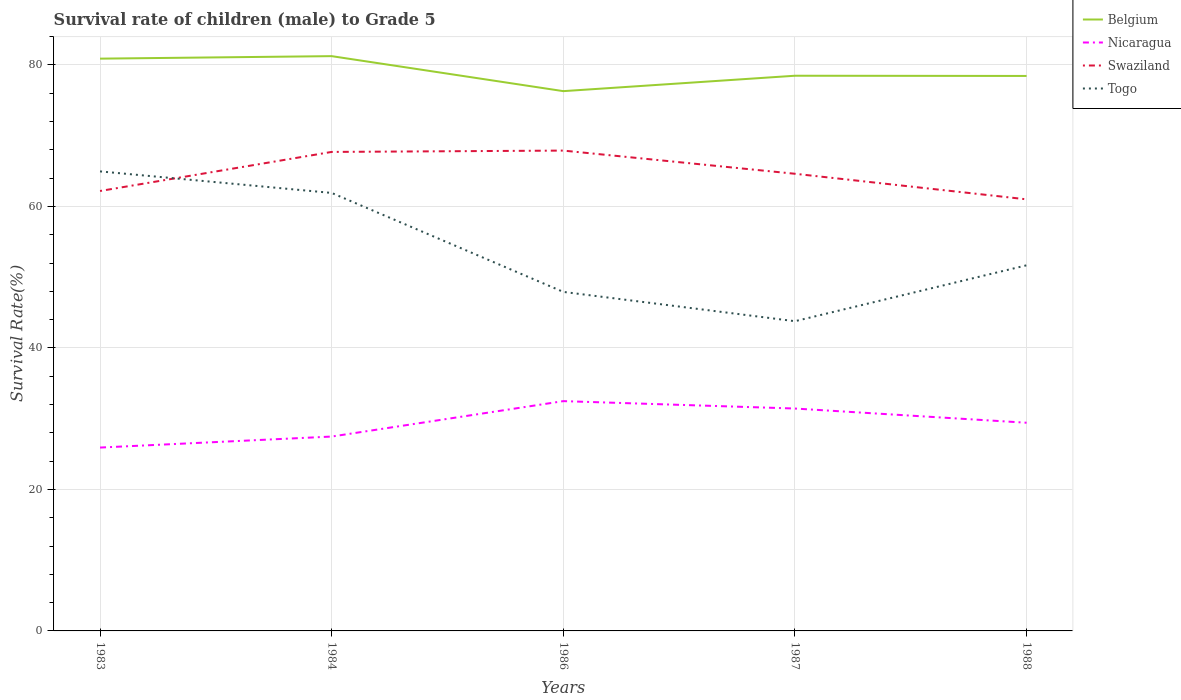How many different coloured lines are there?
Offer a very short reply. 4. Across all years, what is the maximum survival rate of male children to grade 5 in Swaziland?
Provide a succinct answer. 61.01. What is the total survival rate of male children to grade 5 in Belgium in the graph?
Ensure brevity in your answer.  2.8. What is the difference between the highest and the second highest survival rate of male children to grade 5 in Belgium?
Make the answer very short. 4.95. What is the difference between the highest and the lowest survival rate of male children to grade 5 in Swaziland?
Provide a succinct answer. 2. Is the survival rate of male children to grade 5 in Togo strictly greater than the survival rate of male children to grade 5 in Nicaragua over the years?
Your answer should be compact. No. How many lines are there?
Your answer should be very brief. 4. What is the difference between two consecutive major ticks on the Y-axis?
Offer a very short reply. 20. Does the graph contain any zero values?
Your answer should be very brief. No. Does the graph contain grids?
Keep it short and to the point. Yes. How many legend labels are there?
Give a very brief answer. 4. What is the title of the graph?
Give a very brief answer. Survival rate of children (male) to Grade 5. What is the label or title of the Y-axis?
Your answer should be very brief. Survival Rate(%). What is the Survival Rate(%) in Belgium in 1983?
Offer a terse response. 80.89. What is the Survival Rate(%) of Nicaragua in 1983?
Offer a terse response. 25.92. What is the Survival Rate(%) of Swaziland in 1983?
Give a very brief answer. 62.19. What is the Survival Rate(%) of Togo in 1983?
Provide a succinct answer. 64.96. What is the Survival Rate(%) in Belgium in 1984?
Your answer should be very brief. 81.25. What is the Survival Rate(%) of Nicaragua in 1984?
Your response must be concise. 27.47. What is the Survival Rate(%) of Swaziland in 1984?
Give a very brief answer. 67.71. What is the Survival Rate(%) in Togo in 1984?
Your response must be concise. 61.91. What is the Survival Rate(%) of Belgium in 1986?
Ensure brevity in your answer.  76.3. What is the Survival Rate(%) of Nicaragua in 1986?
Keep it short and to the point. 32.48. What is the Survival Rate(%) of Swaziland in 1986?
Provide a succinct answer. 67.9. What is the Survival Rate(%) of Togo in 1986?
Your answer should be very brief. 47.92. What is the Survival Rate(%) of Belgium in 1987?
Your answer should be compact. 78.48. What is the Survival Rate(%) of Nicaragua in 1987?
Make the answer very short. 31.44. What is the Survival Rate(%) in Swaziland in 1987?
Give a very brief answer. 64.62. What is the Survival Rate(%) of Togo in 1987?
Offer a terse response. 43.78. What is the Survival Rate(%) of Belgium in 1988?
Make the answer very short. 78.45. What is the Survival Rate(%) of Nicaragua in 1988?
Your response must be concise. 29.43. What is the Survival Rate(%) in Swaziland in 1988?
Offer a very short reply. 61.01. What is the Survival Rate(%) in Togo in 1988?
Ensure brevity in your answer.  51.68. Across all years, what is the maximum Survival Rate(%) of Belgium?
Offer a terse response. 81.25. Across all years, what is the maximum Survival Rate(%) of Nicaragua?
Offer a very short reply. 32.48. Across all years, what is the maximum Survival Rate(%) of Swaziland?
Offer a terse response. 67.9. Across all years, what is the maximum Survival Rate(%) in Togo?
Your answer should be very brief. 64.96. Across all years, what is the minimum Survival Rate(%) in Belgium?
Offer a terse response. 76.3. Across all years, what is the minimum Survival Rate(%) in Nicaragua?
Make the answer very short. 25.92. Across all years, what is the minimum Survival Rate(%) of Swaziland?
Offer a very short reply. 61.01. Across all years, what is the minimum Survival Rate(%) in Togo?
Give a very brief answer. 43.78. What is the total Survival Rate(%) of Belgium in the graph?
Your answer should be very brief. 395.36. What is the total Survival Rate(%) in Nicaragua in the graph?
Keep it short and to the point. 146.74. What is the total Survival Rate(%) of Swaziland in the graph?
Make the answer very short. 323.42. What is the total Survival Rate(%) in Togo in the graph?
Ensure brevity in your answer.  270.25. What is the difference between the Survival Rate(%) in Belgium in 1983 and that in 1984?
Keep it short and to the point. -0.35. What is the difference between the Survival Rate(%) of Nicaragua in 1983 and that in 1984?
Give a very brief answer. -1.56. What is the difference between the Survival Rate(%) in Swaziland in 1983 and that in 1984?
Your answer should be compact. -5.52. What is the difference between the Survival Rate(%) in Togo in 1983 and that in 1984?
Your answer should be very brief. 3.04. What is the difference between the Survival Rate(%) in Belgium in 1983 and that in 1986?
Offer a terse response. 4.59. What is the difference between the Survival Rate(%) in Nicaragua in 1983 and that in 1986?
Offer a terse response. -6.56. What is the difference between the Survival Rate(%) of Swaziland in 1983 and that in 1986?
Ensure brevity in your answer.  -5.71. What is the difference between the Survival Rate(%) of Togo in 1983 and that in 1986?
Your answer should be very brief. 17.03. What is the difference between the Survival Rate(%) in Belgium in 1983 and that in 1987?
Your answer should be compact. 2.41. What is the difference between the Survival Rate(%) of Nicaragua in 1983 and that in 1987?
Offer a very short reply. -5.52. What is the difference between the Survival Rate(%) of Swaziland in 1983 and that in 1987?
Offer a very short reply. -2.43. What is the difference between the Survival Rate(%) in Togo in 1983 and that in 1987?
Keep it short and to the point. 21.18. What is the difference between the Survival Rate(%) of Belgium in 1983 and that in 1988?
Provide a short and direct response. 2.45. What is the difference between the Survival Rate(%) in Nicaragua in 1983 and that in 1988?
Keep it short and to the point. -3.51. What is the difference between the Survival Rate(%) of Swaziland in 1983 and that in 1988?
Your answer should be compact. 1.18. What is the difference between the Survival Rate(%) in Togo in 1983 and that in 1988?
Offer a very short reply. 13.27. What is the difference between the Survival Rate(%) of Belgium in 1984 and that in 1986?
Provide a short and direct response. 4.95. What is the difference between the Survival Rate(%) in Nicaragua in 1984 and that in 1986?
Your response must be concise. -5.01. What is the difference between the Survival Rate(%) of Swaziland in 1984 and that in 1986?
Your response must be concise. -0.19. What is the difference between the Survival Rate(%) of Togo in 1984 and that in 1986?
Offer a terse response. 13.99. What is the difference between the Survival Rate(%) in Belgium in 1984 and that in 1987?
Provide a short and direct response. 2.77. What is the difference between the Survival Rate(%) in Nicaragua in 1984 and that in 1987?
Make the answer very short. -3.96. What is the difference between the Survival Rate(%) of Swaziland in 1984 and that in 1987?
Your answer should be very brief. 3.09. What is the difference between the Survival Rate(%) of Togo in 1984 and that in 1987?
Make the answer very short. 18.13. What is the difference between the Survival Rate(%) of Belgium in 1984 and that in 1988?
Provide a short and direct response. 2.8. What is the difference between the Survival Rate(%) in Nicaragua in 1984 and that in 1988?
Give a very brief answer. -1.95. What is the difference between the Survival Rate(%) of Swaziland in 1984 and that in 1988?
Offer a terse response. 6.7. What is the difference between the Survival Rate(%) in Togo in 1984 and that in 1988?
Your response must be concise. 10.23. What is the difference between the Survival Rate(%) in Belgium in 1986 and that in 1987?
Make the answer very short. -2.18. What is the difference between the Survival Rate(%) in Nicaragua in 1986 and that in 1987?
Keep it short and to the point. 1.05. What is the difference between the Survival Rate(%) of Swaziland in 1986 and that in 1987?
Give a very brief answer. 3.28. What is the difference between the Survival Rate(%) of Togo in 1986 and that in 1987?
Provide a short and direct response. 4.14. What is the difference between the Survival Rate(%) in Belgium in 1986 and that in 1988?
Your answer should be compact. -2.15. What is the difference between the Survival Rate(%) in Nicaragua in 1986 and that in 1988?
Ensure brevity in your answer.  3.05. What is the difference between the Survival Rate(%) in Swaziland in 1986 and that in 1988?
Offer a very short reply. 6.89. What is the difference between the Survival Rate(%) of Togo in 1986 and that in 1988?
Your answer should be compact. -3.76. What is the difference between the Survival Rate(%) in Belgium in 1987 and that in 1988?
Keep it short and to the point. 0.03. What is the difference between the Survival Rate(%) in Nicaragua in 1987 and that in 1988?
Keep it short and to the point. 2.01. What is the difference between the Survival Rate(%) in Swaziland in 1987 and that in 1988?
Your answer should be very brief. 3.61. What is the difference between the Survival Rate(%) in Togo in 1987 and that in 1988?
Your response must be concise. -7.9. What is the difference between the Survival Rate(%) in Belgium in 1983 and the Survival Rate(%) in Nicaragua in 1984?
Your answer should be compact. 53.42. What is the difference between the Survival Rate(%) of Belgium in 1983 and the Survival Rate(%) of Swaziland in 1984?
Your answer should be very brief. 13.18. What is the difference between the Survival Rate(%) of Belgium in 1983 and the Survival Rate(%) of Togo in 1984?
Give a very brief answer. 18.98. What is the difference between the Survival Rate(%) of Nicaragua in 1983 and the Survival Rate(%) of Swaziland in 1984?
Your answer should be very brief. -41.79. What is the difference between the Survival Rate(%) in Nicaragua in 1983 and the Survival Rate(%) in Togo in 1984?
Provide a short and direct response. -35.99. What is the difference between the Survival Rate(%) of Swaziland in 1983 and the Survival Rate(%) of Togo in 1984?
Your response must be concise. 0.27. What is the difference between the Survival Rate(%) of Belgium in 1983 and the Survival Rate(%) of Nicaragua in 1986?
Your answer should be compact. 48.41. What is the difference between the Survival Rate(%) of Belgium in 1983 and the Survival Rate(%) of Swaziland in 1986?
Your answer should be very brief. 13. What is the difference between the Survival Rate(%) of Belgium in 1983 and the Survival Rate(%) of Togo in 1986?
Provide a short and direct response. 32.97. What is the difference between the Survival Rate(%) of Nicaragua in 1983 and the Survival Rate(%) of Swaziland in 1986?
Make the answer very short. -41.98. What is the difference between the Survival Rate(%) of Nicaragua in 1983 and the Survival Rate(%) of Togo in 1986?
Ensure brevity in your answer.  -22. What is the difference between the Survival Rate(%) in Swaziland in 1983 and the Survival Rate(%) in Togo in 1986?
Your answer should be compact. 14.26. What is the difference between the Survival Rate(%) of Belgium in 1983 and the Survival Rate(%) of Nicaragua in 1987?
Your answer should be very brief. 49.46. What is the difference between the Survival Rate(%) of Belgium in 1983 and the Survival Rate(%) of Swaziland in 1987?
Your response must be concise. 16.27. What is the difference between the Survival Rate(%) in Belgium in 1983 and the Survival Rate(%) in Togo in 1987?
Your answer should be very brief. 37.11. What is the difference between the Survival Rate(%) in Nicaragua in 1983 and the Survival Rate(%) in Swaziland in 1987?
Offer a very short reply. -38.7. What is the difference between the Survival Rate(%) in Nicaragua in 1983 and the Survival Rate(%) in Togo in 1987?
Make the answer very short. -17.86. What is the difference between the Survival Rate(%) in Swaziland in 1983 and the Survival Rate(%) in Togo in 1987?
Your answer should be very brief. 18.41. What is the difference between the Survival Rate(%) in Belgium in 1983 and the Survival Rate(%) in Nicaragua in 1988?
Make the answer very short. 51.46. What is the difference between the Survival Rate(%) in Belgium in 1983 and the Survival Rate(%) in Swaziland in 1988?
Keep it short and to the point. 19.89. What is the difference between the Survival Rate(%) in Belgium in 1983 and the Survival Rate(%) in Togo in 1988?
Offer a very short reply. 29.21. What is the difference between the Survival Rate(%) in Nicaragua in 1983 and the Survival Rate(%) in Swaziland in 1988?
Offer a terse response. -35.09. What is the difference between the Survival Rate(%) in Nicaragua in 1983 and the Survival Rate(%) in Togo in 1988?
Offer a very short reply. -25.76. What is the difference between the Survival Rate(%) in Swaziland in 1983 and the Survival Rate(%) in Togo in 1988?
Give a very brief answer. 10.5. What is the difference between the Survival Rate(%) of Belgium in 1984 and the Survival Rate(%) of Nicaragua in 1986?
Offer a very short reply. 48.76. What is the difference between the Survival Rate(%) in Belgium in 1984 and the Survival Rate(%) in Swaziland in 1986?
Your answer should be compact. 13.35. What is the difference between the Survival Rate(%) in Belgium in 1984 and the Survival Rate(%) in Togo in 1986?
Your answer should be very brief. 33.32. What is the difference between the Survival Rate(%) of Nicaragua in 1984 and the Survival Rate(%) of Swaziland in 1986?
Offer a very short reply. -40.42. What is the difference between the Survival Rate(%) of Nicaragua in 1984 and the Survival Rate(%) of Togo in 1986?
Offer a terse response. -20.45. What is the difference between the Survival Rate(%) in Swaziland in 1984 and the Survival Rate(%) in Togo in 1986?
Ensure brevity in your answer.  19.79. What is the difference between the Survival Rate(%) of Belgium in 1984 and the Survival Rate(%) of Nicaragua in 1987?
Provide a short and direct response. 49.81. What is the difference between the Survival Rate(%) of Belgium in 1984 and the Survival Rate(%) of Swaziland in 1987?
Offer a terse response. 16.63. What is the difference between the Survival Rate(%) in Belgium in 1984 and the Survival Rate(%) in Togo in 1987?
Give a very brief answer. 37.47. What is the difference between the Survival Rate(%) in Nicaragua in 1984 and the Survival Rate(%) in Swaziland in 1987?
Make the answer very short. -37.15. What is the difference between the Survival Rate(%) of Nicaragua in 1984 and the Survival Rate(%) of Togo in 1987?
Your answer should be very brief. -16.31. What is the difference between the Survival Rate(%) of Swaziland in 1984 and the Survival Rate(%) of Togo in 1987?
Provide a short and direct response. 23.93. What is the difference between the Survival Rate(%) of Belgium in 1984 and the Survival Rate(%) of Nicaragua in 1988?
Ensure brevity in your answer.  51.82. What is the difference between the Survival Rate(%) in Belgium in 1984 and the Survival Rate(%) in Swaziland in 1988?
Provide a succinct answer. 20.24. What is the difference between the Survival Rate(%) of Belgium in 1984 and the Survival Rate(%) of Togo in 1988?
Provide a short and direct response. 29.56. What is the difference between the Survival Rate(%) in Nicaragua in 1984 and the Survival Rate(%) in Swaziland in 1988?
Your answer should be very brief. -33.53. What is the difference between the Survival Rate(%) of Nicaragua in 1984 and the Survival Rate(%) of Togo in 1988?
Ensure brevity in your answer.  -24.21. What is the difference between the Survival Rate(%) in Swaziland in 1984 and the Survival Rate(%) in Togo in 1988?
Ensure brevity in your answer.  16.03. What is the difference between the Survival Rate(%) in Belgium in 1986 and the Survival Rate(%) in Nicaragua in 1987?
Provide a succinct answer. 44.86. What is the difference between the Survival Rate(%) in Belgium in 1986 and the Survival Rate(%) in Swaziland in 1987?
Your answer should be very brief. 11.68. What is the difference between the Survival Rate(%) in Belgium in 1986 and the Survival Rate(%) in Togo in 1987?
Provide a short and direct response. 32.52. What is the difference between the Survival Rate(%) of Nicaragua in 1986 and the Survival Rate(%) of Swaziland in 1987?
Your response must be concise. -32.14. What is the difference between the Survival Rate(%) in Nicaragua in 1986 and the Survival Rate(%) in Togo in 1987?
Offer a terse response. -11.3. What is the difference between the Survival Rate(%) of Swaziland in 1986 and the Survival Rate(%) of Togo in 1987?
Provide a short and direct response. 24.12. What is the difference between the Survival Rate(%) of Belgium in 1986 and the Survival Rate(%) of Nicaragua in 1988?
Your answer should be compact. 46.87. What is the difference between the Survival Rate(%) of Belgium in 1986 and the Survival Rate(%) of Swaziland in 1988?
Your response must be concise. 15.29. What is the difference between the Survival Rate(%) of Belgium in 1986 and the Survival Rate(%) of Togo in 1988?
Offer a very short reply. 24.62. What is the difference between the Survival Rate(%) in Nicaragua in 1986 and the Survival Rate(%) in Swaziland in 1988?
Make the answer very short. -28.53. What is the difference between the Survival Rate(%) of Nicaragua in 1986 and the Survival Rate(%) of Togo in 1988?
Ensure brevity in your answer.  -19.2. What is the difference between the Survival Rate(%) of Swaziland in 1986 and the Survival Rate(%) of Togo in 1988?
Ensure brevity in your answer.  16.22. What is the difference between the Survival Rate(%) of Belgium in 1987 and the Survival Rate(%) of Nicaragua in 1988?
Your answer should be very brief. 49.05. What is the difference between the Survival Rate(%) of Belgium in 1987 and the Survival Rate(%) of Swaziland in 1988?
Give a very brief answer. 17.47. What is the difference between the Survival Rate(%) of Belgium in 1987 and the Survival Rate(%) of Togo in 1988?
Keep it short and to the point. 26.8. What is the difference between the Survival Rate(%) in Nicaragua in 1987 and the Survival Rate(%) in Swaziland in 1988?
Offer a terse response. -29.57. What is the difference between the Survival Rate(%) in Nicaragua in 1987 and the Survival Rate(%) in Togo in 1988?
Your answer should be compact. -20.25. What is the difference between the Survival Rate(%) in Swaziland in 1987 and the Survival Rate(%) in Togo in 1988?
Your answer should be compact. 12.94. What is the average Survival Rate(%) of Belgium per year?
Offer a terse response. 79.07. What is the average Survival Rate(%) in Nicaragua per year?
Make the answer very short. 29.35. What is the average Survival Rate(%) in Swaziland per year?
Your answer should be compact. 64.68. What is the average Survival Rate(%) of Togo per year?
Provide a short and direct response. 54.05. In the year 1983, what is the difference between the Survival Rate(%) in Belgium and Survival Rate(%) in Nicaragua?
Your answer should be compact. 54.97. In the year 1983, what is the difference between the Survival Rate(%) of Belgium and Survival Rate(%) of Swaziland?
Keep it short and to the point. 18.71. In the year 1983, what is the difference between the Survival Rate(%) in Belgium and Survival Rate(%) in Togo?
Ensure brevity in your answer.  15.94. In the year 1983, what is the difference between the Survival Rate(%) of Nicaragua and Survival Rate(%) of Swaziland?
Your answer should be very brief. -36.27. In the year 1983, what is the difference between the Survival Rate(%) of Nicaragua and Survival Rate(%) of Togo?
Offer a terse response. -39.04. In the year 1983, what is the difference between the Survival Rate(%) of Swaziland and Survival Rate(%) of Togo?
Ensure brevity in your answer.  -2.77. In the year 1984, what is the difference between the Survival Rate(%) in Belgium and Survival Rate(%) in Nicaragua?
Offer a terse response. 53.77. In the year 1984, what is the difference between the Survival Rate(%) in Belgium and Survival Rate(%) in Swaziland?
Offer a very short reply. 13.54. In the year 1984, what is the difference between the Survival Rate(%) in Belgium and Survival Rate(%) in Togo?
Make the answer very short. 19.33. In the year 1984, what is the difference between the Survival Rate(%) in Nicaragua and Survival Rate(%) in Swaziland?
Give a very brief answer. -40.23. In the year 1984, what is the difference between the Survival Rate(%) of Nicaragua and Survival Rate(%) of Togo?
Ensure brevity in your answer.  -34.44. In the year 1984, what is the difference between the Survival Rate(%) of Swaziland and Survival Rate(%) of Togo?
Offer a terse response. 5.8. In the year 1986, what is the difference between the Survival Rate(%) of Belgium and Survival Rate(%) of Nicaragua?
Offer a very short reply. 43.82. In the year 1986, what is the difference between the Survival Rate(%) in Belgium and Survival Rate(%) in Swaziland?
Provide a short and direct response. 8.4. In the year 1986, what is the difference between the Survival Rate(%) in Belgium and Survival Rate(%) in Togo?
Provide a succinct answer. 28.38. In the year 1986, what is the difference between the Survival Rate(%) in Nicaragua and Survival Rate(%) in Swaziland?
Your answer should be very brief. -35.42. In the year 1986, what is the difference between the Survival Rate(%) of Nicaragua and Survival Rate(%) of Togo?
Your answer should be compact. -15.44. In the year 1986, what is the difference between the Survival Rate(%) in Swaziland and Survival Rate(%) in Togo?
Keep it short and to the point. 19.98. In the year 1987, what is the difference between the Survival Rate(%) of Belgium and Survival Rate(%) of Nicaragua?
Ensure brevity in your answer.  47.04. In the year 1987, what is the difference between the Survival Rate(%) of Belgium and Survival Rate(%) of Swaziland?
Ensure brevity in your answer.  13.86. In the year 1987, what is the difference between the Survival Rate(%) of Belgium and Survival Rate(%) of Togo?
Your response must be concise. 34.7. In the year 1987, what is the difference between the Survival Rate(%) in Nicaragua and Survival Rate(%) in Swaziland?
Your response must be concise. -33.18. In the year 1987, what is the difference between the Survival Rate(%) in Nicaragua and Survival Rate(%) in Togo?
Keep it short and to the point. -12.34. In the year 1987, what is the difference between the Survival Rate(%) of Swaziland and Survival Rate(%) of Togo?
Provide a short and direct response. 20.84. In the year 1988, what is the difference between the Survival Rate(%) in Belgium and Survival Rate(%) in Nicaragua?
Make the answer very short. 49.02. In the year 1988, what is the difference between the Survival Rate(%) in Belgium and Survival Rate(%) in Swaziland?
Your answer should be very brief. 17.44. In the year 1988, what is the difference between the Survival Rate(%) of Belgium and Survival Rate(%) of Togo?
Keep it short and to the point. 26.77. In the year 1988, what is the difference between the Survival Rate(%) in Nicaragua and Survival Rate(%) in Swaziland?
Offer a terse response. -31.58. In the year 1988, what is the difference between the Survival Rate(%) of Nicaragua and Survival Rate(%) of Togo?
Make the answer very short. -22.25. In the year 1988, what is the difference between the Survival Rate(%) in Swaziland and Survival Rate(%) in Togo?
Provide a short and direct response. 9.33. What is the ratio of the Survival Rate(%) in Belgium in 1983 to that in 1984?
Keep it short and to the point. 1. What is the ratio of the Survival Rate(%) in Nicaragua in 1983 to that in 1984?
Keep it short and to the point. 0.94. What is the ratio of the Survival Rate(%) of Swaziland in 1983 to that in 1984?
Keep it short and to the point. 0.92. What is the ratio of the Survival Rate(%) of Togo in 1983 to that in 1984?
Make the answer very short. 1.05. What is the ratio of the Survival Rate(%) of Belgium in 1983 to that in 1986?
Make the answer very short. 1.06. What is the ratio of the Survival Rate(%) in Nicaragua in 1983 to that in 1986?
Your response must be concise. 0.8. What is the ratio of the Survival Rate(%) of Swaziland in 1983 to that in 1986?
Your response must be concise. 0.92. What is the ratio of the Survival Rate(%) in Togo in 1983 to that in 1986?
Keep it short and to the point. 1.36. What is the ratio of the Survival Rate(%) of Belgium in 1983 to that in 1987?
Your answer should be very brief. 1.03. What is the ratio of the Survival Rate(%) of Nicaragua in 1983 to that in 1987?
Ensure brevity in your answer.  0.82. What is the ratio of the Survival Rate(%) in Swaziland in 1983 to that in 1987?
Your answer should be compact. 0.96. What is the ratio of the Survival Rate(%) in Togo in 1983 to that in 1987?
Your answer should be very brief. 1.48. What is the ratio of the Survival Rate(%) in Belgium in 1983 to that in 1988?
Provide a succinct answer. 1.03. What is the ratio of the Survival Rate(%) in Nicaragua in 1983 to that in 1988?
Your response must be concise. 0.88. What is the ratio of the Survival Rate(%) in Swaziland in 1983 to that in 1988?
Keep it short and to the point. 1.02. What is the ratio of the Survival Rate(%) in Togo in 1983 to that in 1988?
Offer a terse response. 1.26. What is the ratio of the Survival Rate(%) in Belgium in 1984 to that in 1986?
Provide a succinct answer. 1.06. What is the ratio of the Survival Rate(%) of Nicaragua in 1984 to that in 1986?
Your answer should be compact. 0.85. What is the ratio of the Survival Rate(%) of Swaziland in 1984 to that in 1986?
Your answer should be very brief. 1. What is the ratio of the Survival Rate(%) in Togo in 1984 to that in 1986?
Give a very brief answer. 1.29. What is the ratio of the Survival Rate(%) in Belgium in 1984 to that in 1987?
Your response must be concise. 1.04. What is the ratio of the Survival Rate(%) in Nicaragua in 1984 to that in 1987?
Keep it short and to the point. 0.87. What is the ratio of the Survival Rate(%) of Swaziland in 1984 to that in 1987?
Make the answer very short. 1.05. What is the ratio of the Survival Rate(%) of Togo in 1984 to that in 1987?
Ensure brevity in your answer.  1.41. What is the ratio of the Survival Rate(%) of Belgium in 1984 to that in 1988?
Ensure brevity in your answer.  1.04. What is the ratio of the Survival Rate(%) in Nicaragua in 1984 to that in 1988?
Offer a very short reply. 0.93. What is the ratio of the Survival Rate(%) in Swaziland in 1984 to that in 1988?
Your response must be concise. 1.11. What is the ratio of the Survival Rate(%) in Togo in 1984 to that in 1988?
Your answer should be very brief. 1.2. What is the ratio of the Survival Rate(%) of Belgium in 1986 to that in 1987?
Provide a short and direct response. 0.97. What is the ratio of the Survival Rate(%) of Nicaragua in 1986 to that in 1987?
Your response must be concise. 1.03. What is the ratio of the Survival Rate(%) in Swaziland in 1986 to that in 1987?
Offer a terse response. 1.05. What is the ratio of the Survival Rate(%) of Togo in 1986 to that in 1987?
Offer a terse response. 1.09. What is the ratio of the Survival Rate(%) of Belgium in 1986 to that in 1988?
Offer a terse response. 0.97. What is the ratio of the Survival Rate(%) in Nicaragua in 1986 to that in 1988?
Offer a very short reply. 1.1. What is the ratio of the Survival Rate(%) of Swaziland in 1986 to that in 1988?
Offer a terse response. 1.11. What is the ratio of the Survival Rate(%) of Togo in 1986 to that in 1988?
Offer a terse response. 0.93. What is the ratio of the Survival Rate(%) of Nicaragua in 1987 to that in 1988?
Give a very brief answer. 1.07. What is the ratio of the Survival Rate(%) in Swaziland in 1987 to that in 1988?
Provide a succinct answer. 1.06. What is the ratio of the Survival Rate(%) of Togo in 1987 to that in 1988?
Your response must be concise. 0.85. What is the difference between the highest and the second highest Survival Rate(%) of Belgium?
Offer a very short reply. 0.35. What is the difference between the highest and the second highest Survival Rate(%) of Nicaragua?
Ensure brevity in your answer.  1.05. What is the difference between the highest and the second highest Survival Rate(%) of Swaziland?
Offer a very short reply. 0.19. What is the difference between the highest and the second highest Survival Rate(%) of Togo?
Your answer should be very brief. 3.04. What is the difference between the highest and the lowest Survival Rate(%) in Belgium?
Make the answer very short. 4.95. What is the difference between the highest and the lowest Survival Rate(%) of Nicaragua?
Your response must be concise. 6.56. What is the difference between the highest and the lowest Survival Rate(%) in Swaziland?
Your answer should be very brief. 6.89. What is the difference between the highest and the lowest Survival Rate(%) in Togo?
Ensure brevity in your answer.  21.18. 